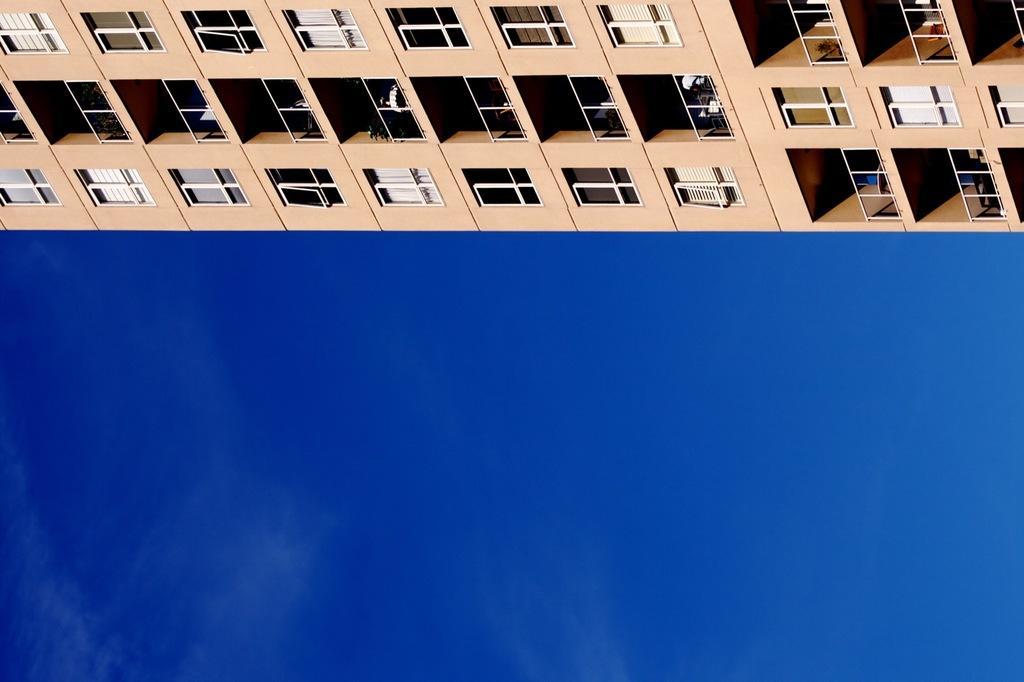How would you summarize this image in a sentence or two? In this picture we can see a building, few metal rods and curtains. 